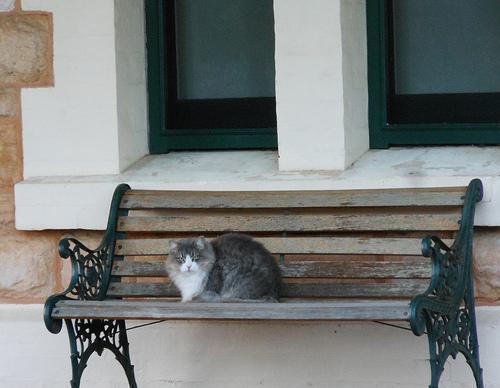How many windows are visible?
Give a very brief answer. 2. 